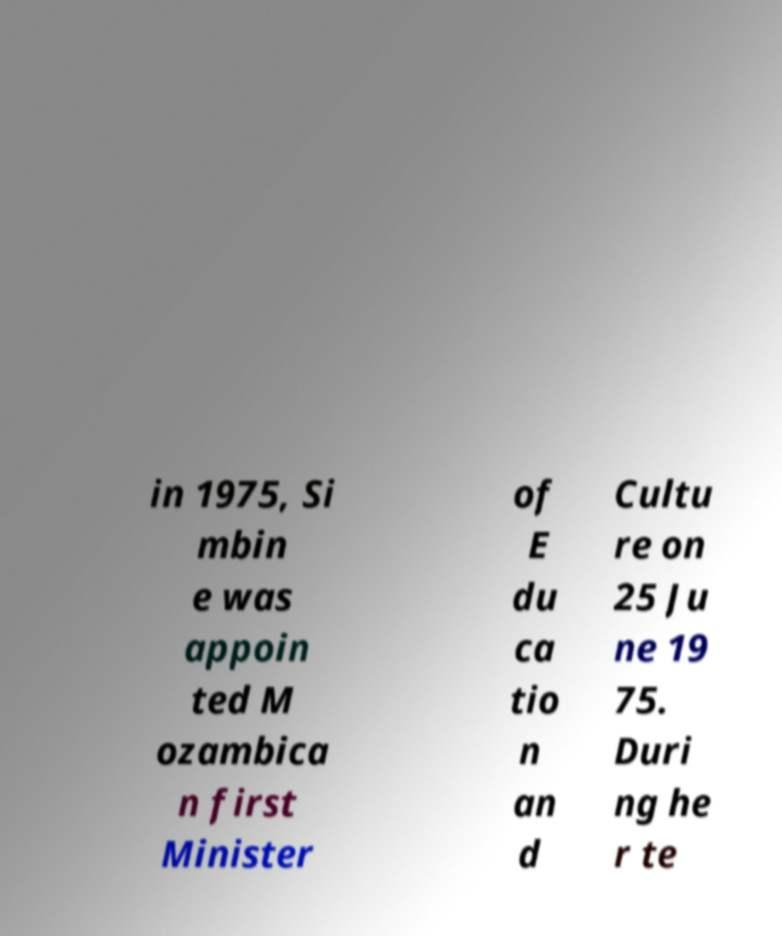There's text embedded in this image that I need extracted. Can you transcribe it verbatim? in 1975, Si mbin e was appoin ted M ozambica n first Minister of E du ca tio n an d Cultu re on 25 Ju ne 19 75. Duri ng he r te 